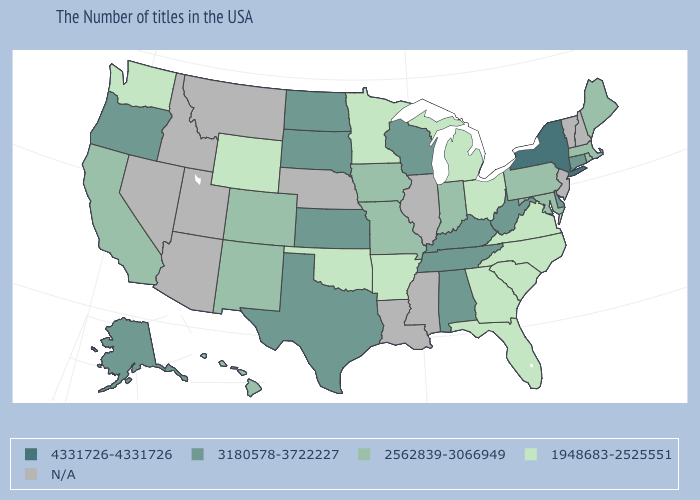Name the states that have a value in the range 1948683-2525551?
Concise answer only. Virginia, North Carolina, South Carolina, Ohio, Florida, Georgia, Michigan, Arkansas, Minnesota, Oklahoma, Wyoming, Washington. Among the states that border Wyoming , which have the lowest value?
Keep it brief. Colorado. Which states have the highest value in the USA?
Keep it brief. New York. Is the legend a continuous bar?
Concise answer only. No. Name the states that have a value in the range N/A?
Concise answer only. New Hampshire, Vermont, New Jersey, Illinois, Mississippi, Louisiana, Nebraska, Utah, Montana, Arizona, Idaho, Nevada. Which states have the lowest value in the Northeast?
Write a very short answer. Maine, Massachusetts, Rhode Island, Pennsylvania. What is the highest value in states that border Maryland?
Short answer required. 3180578-3722227. Does Oregon have the lowest value in the West?
Concise answer only. No. Name the states that have a value in the range N/A?
Write a very short answer. New Hampshire, Vermont, New Jersey, Illinois, Mississippi, Louisiana, Nebraska, Utah, Montana, Arizona, Idaho, Nevada. What is the lowest value in the MidWest?
Short answer required. 1948683-2525551. Name the states that have a value in the range 1948683-2525551?
Quick response, please. Virginia, North Carolina, South Carolina, Ohio, Florida, Georgia, Michigan, Arkansas, Minnesota, Oklahoma, Wyoming, Washington. What is the lowest value in states that border Minnesota?
Be succinct. 2562839-3066949. 